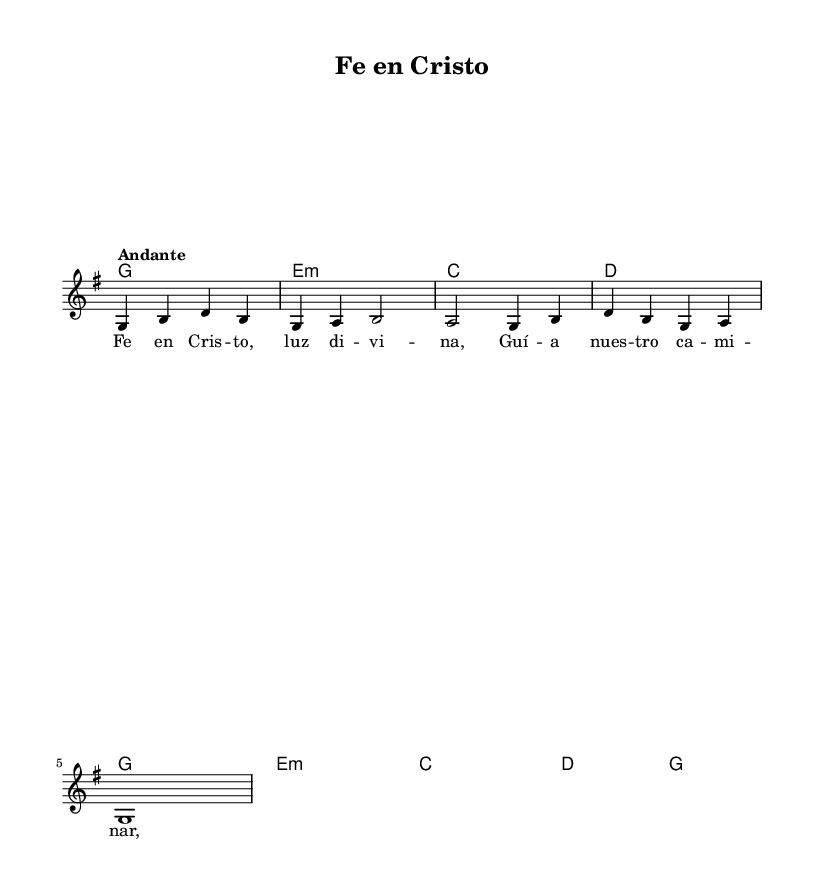What is the key signature of this music? The key signature is G major, which has one sharp (F#). This can be identified in the sheet music by looking at the key signature indication that is located at the beginning of the staff.
Answer: G major What is the time signature of this music? The time signature is 4/4, which means there are four beats in each measure and the quarter note receives one beat. This is represented at the beginning of the piece right after the key signature.
Answer: 4/4 What is the tempo marking of this piece? The tempo marking is "Andante," which is a moderate pace, typically meaning "at a walking speed." It is written above the musical staff as a directive for the speed of performance.
Answer: Andante How many measures are in the melody? There are four measures in the melody section, which can be counted by looking at the divisions created by the vertical lines (bars) in the staff that separate the musical phrases.
Answer: 4 What is the tonic chord of this piece? The tonic chord is G major, as indicated by the first harmony and the root of the scale represented in the chord symbols throughout the piece. This reflects the tonal center around which the melody is built.
Answer: G What is the first lyric of the hymn? The first lyric of the hymn is "Fe en Cristo." This can be found directly under the first note of the melody where lyrics are aligned with the musical notes, showing the text that corresponds to that melodic part.
Answer: Fe en Cristo What chord follows the E minor in the harmonies? The chord that follows the E minor is C major, which comes immediately after the E minor chord in the sequence shown. This can be identified in the chord mode section of the score where each chord is vertically aligned.
Answer: C major 